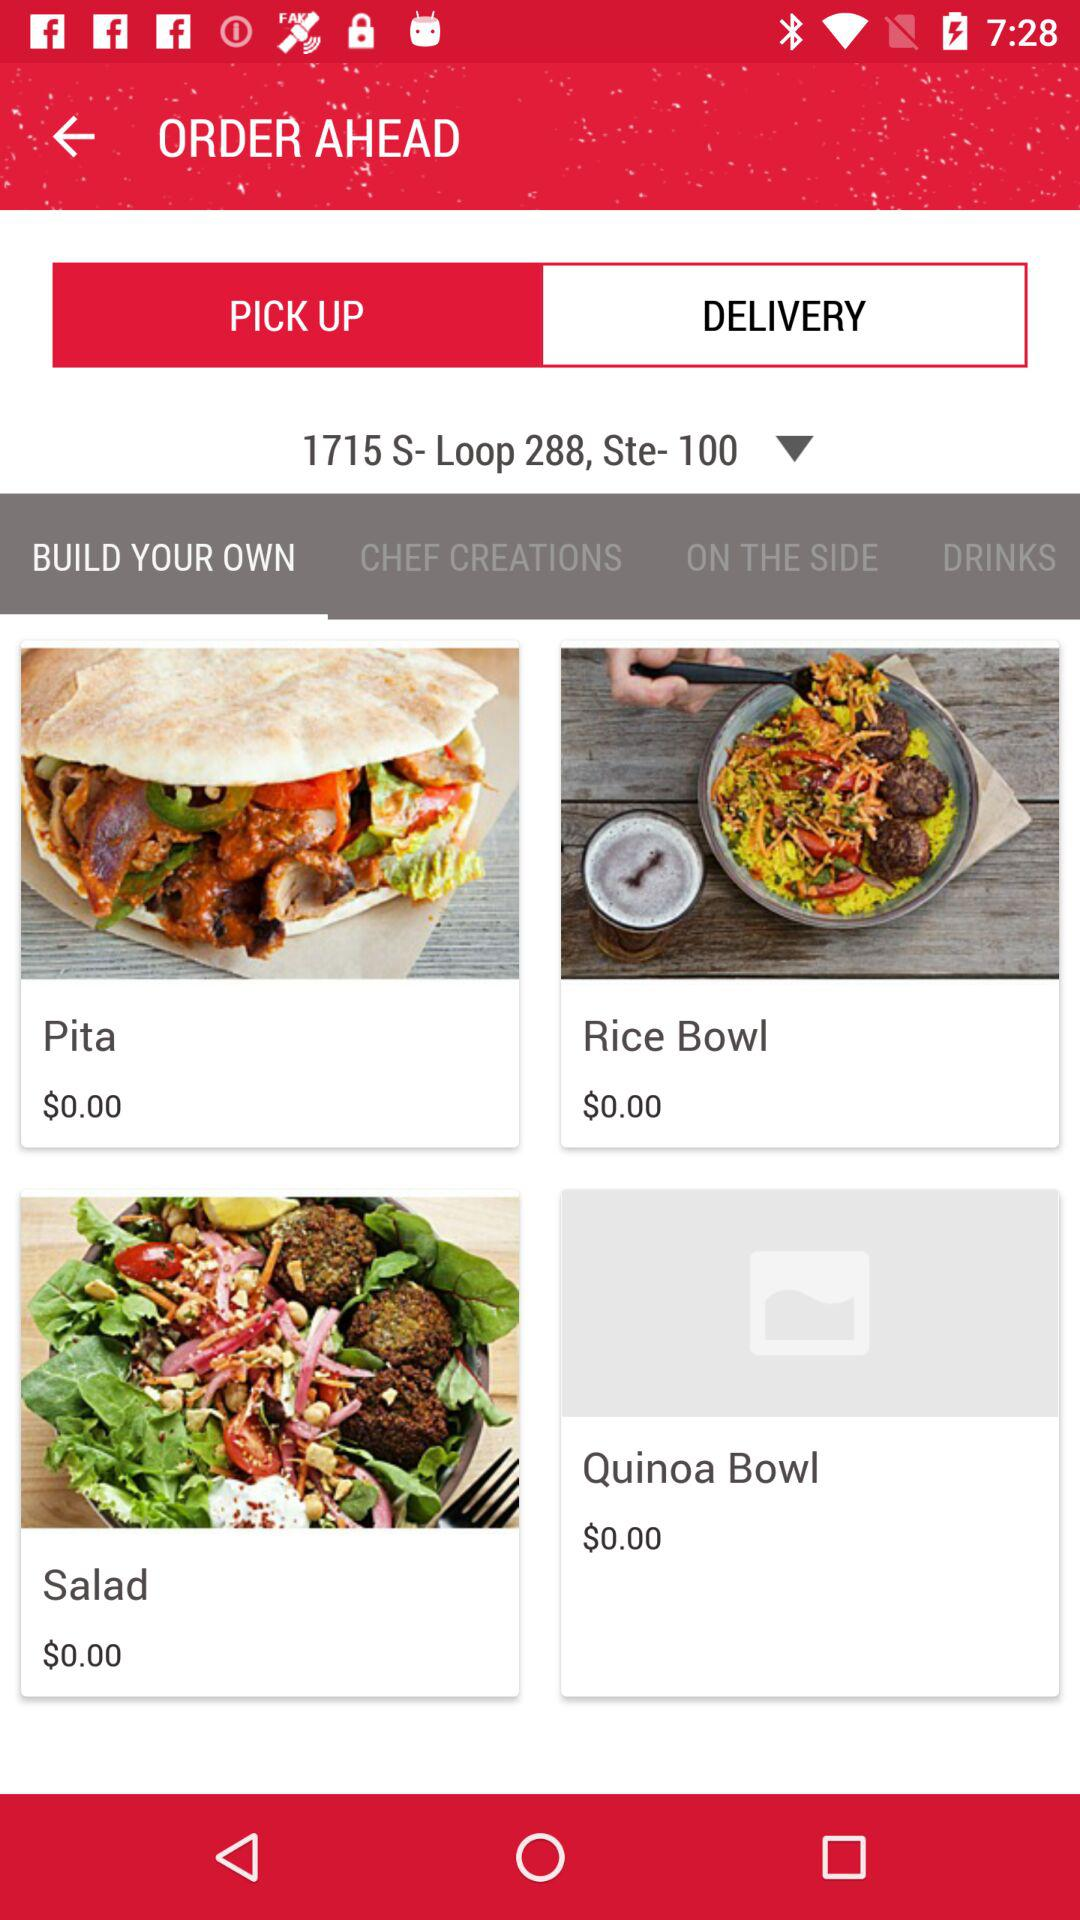What is the price of "Rice Bowl"? The price of "Rice Bowl" is $0.00. 